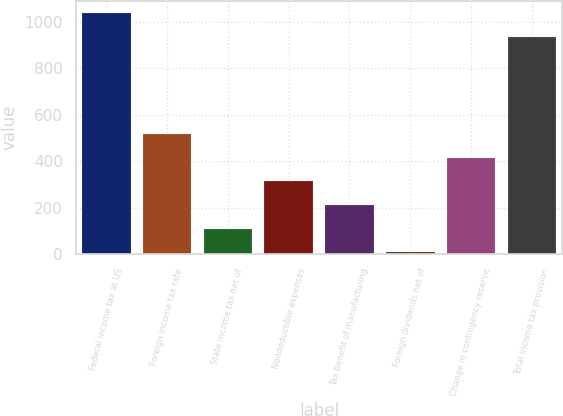<chart> <loc_0><loc_0><loc_500><loc_500><bar_chart><fcel>Federal income tax at US<fcel>Foreign income tax rate<fcel>State income tax net of<fcel>Nondeductible expenses<fcel>Tax benefit of manufacturing<fcel>Foreign dividends net of<fcel>Change in contingency reserve<fcel>Total income tax provision<nl><fcel>1038.4<fcel>516<fcel>110.4<fcel>313.2<fcel>211.8<fcel>9<fcel>414.6<fcel>937<nl></chart> 